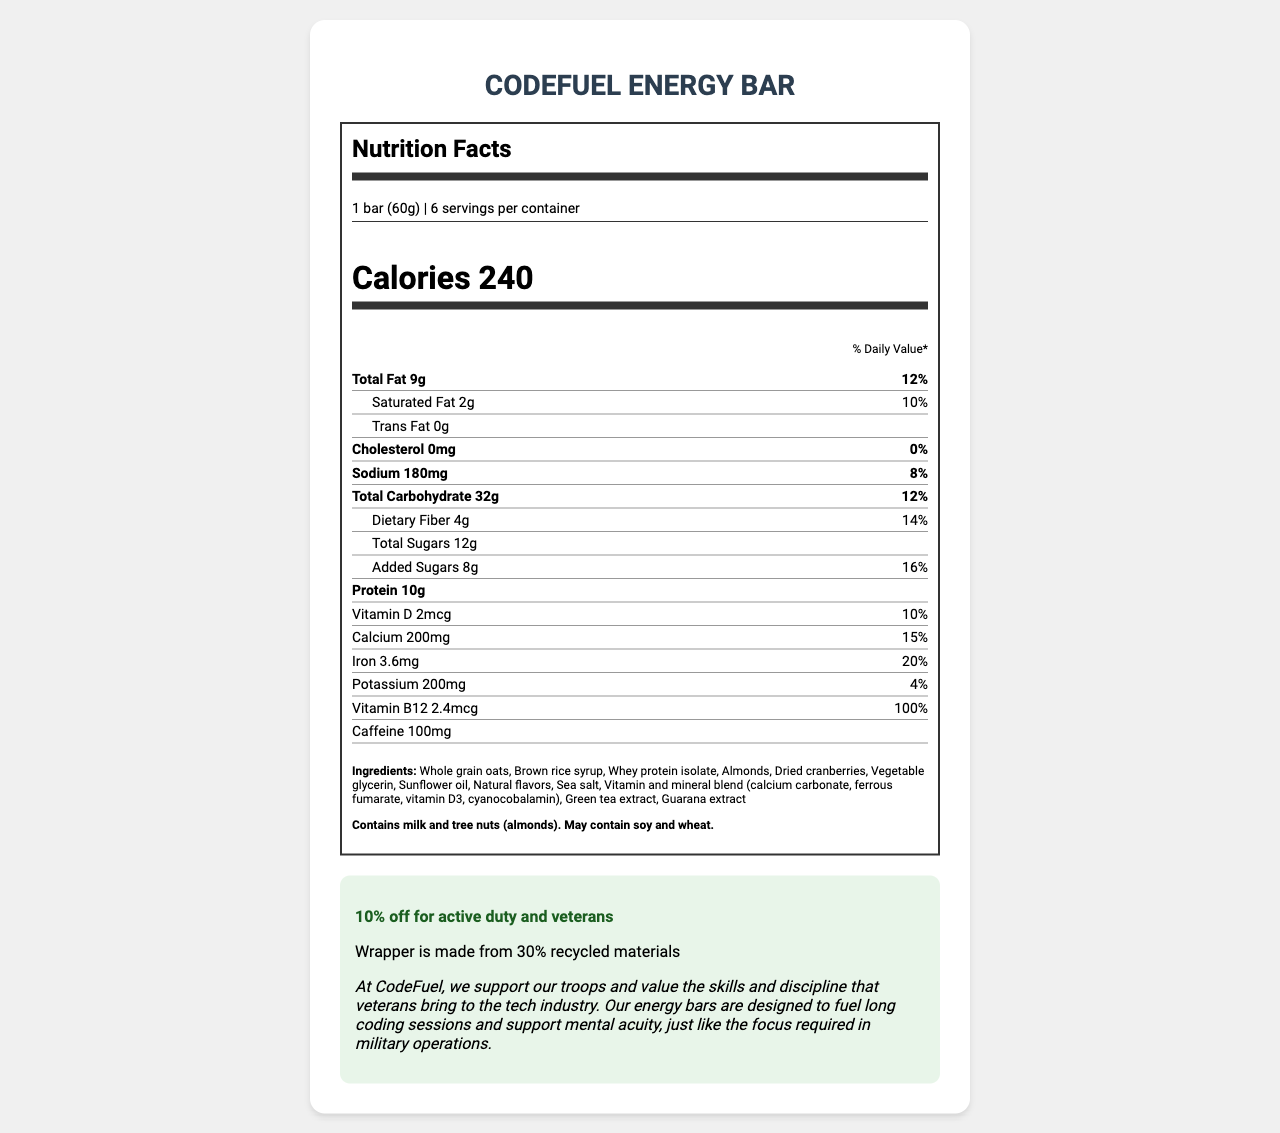what is the serving size of the CodeFuel Energy Bar? The serving size is clearly stated at the top of the Nutrition Facts Label as "1 bar (60g)".
Answer: 1 bar (60g) how many calories are there per serving? The label lists "Calories 240" prominently below the serving information.
Answer: 240 calories what is the amount of protein per serving? The Nutrition Facts Label specifies "Protein 10g".
Answer: 10g what percentage of the daily value for calcium does one serving provide? The item for calcium indicates "15%" under the % Daily Value column.
Answer: 15% can you list the allergens present in the CodeFuel Energy Bar? This information is provided in the allergen info section at the bottom of the Nutrition Facts Label.
Answer: Milk and tree nuts (almonds). May contain soy and wheat. which vitamin is provided at 100% daily value in the CodeFuel Energy Bar? The label shows "Vitamin B12 100%" in the % Daily Value column.
Answer: Vitamin B12 how much caffeine is in one serving of the CodeFuel Energy Bar? The label lists "Caffeine 100mg".
Answer: 100mg which of the following ingredients is NOT in the CodeFuel Energy Bar?  A. Almonds  B. Honey  C. Whole grain oats  D. Brown rice syrup The ingredient list includes almonds, whole grain oats, and brown rice syrup but not honey.
Answer: B. Honey what is the total fat content per serving? A. 9g  B. 12g  C. 2g  D. 8g The total fat is listed as "Total Fat 9g".
Answer: A. 9g is there any trans fat in the CodeFuel Energy Bar? The label specifies "Trans Fat 0g".
Answer: No describe the main idea of the document. The label presents the product's nutritional breakdown, serving size, and how it supports software developers, particularly veterans.
Answer: The document provides a detailed overview of the nutritional information, ingredients, allergens, additional info such as military discount, and company statement for the CodeFuel Energy Bar. what flavorings are used in the CodeFuel Energy Bar? The document only mentions "Natural flavors" without specifying which flavorings are used.
Answer: Cannot be determined 